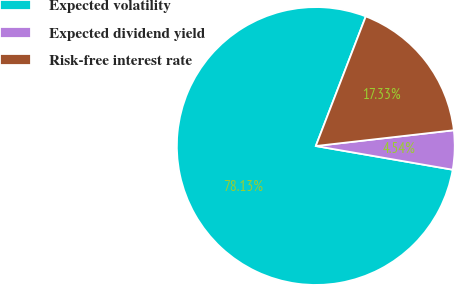<chart> <loc_0><loc_0><loc_500><loc_500><pie_chart><fcel>Expected volatility<fcel>Expected dividend yield<fcel>Risk-free interest rate<nl><fcel>78.13%<fcel>4.54%<fcel>17.33%<nl></chart> 